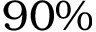Convert formula to latex. <formula><loc_0><loc_0><loc_500><loc_500>9 0 \%</formula> 